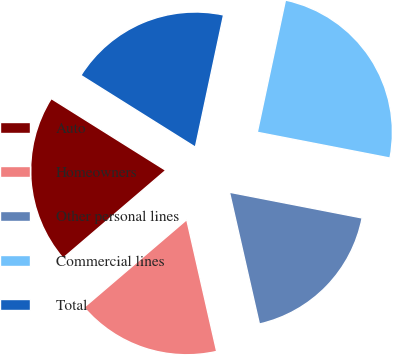Convert chart. <chart><loc_0><loc_0><loc_500><loc_500><pie_chart><fcel>Auto<fcel>Homeowners<fcel>Other personal lines<fcel>Commercial lines<fcel>Total<nl><fcel>20.17%<fcel>17.3%<fcel>18.39%<fcel>24.71%<fcel>19.43%<nl></chart> 